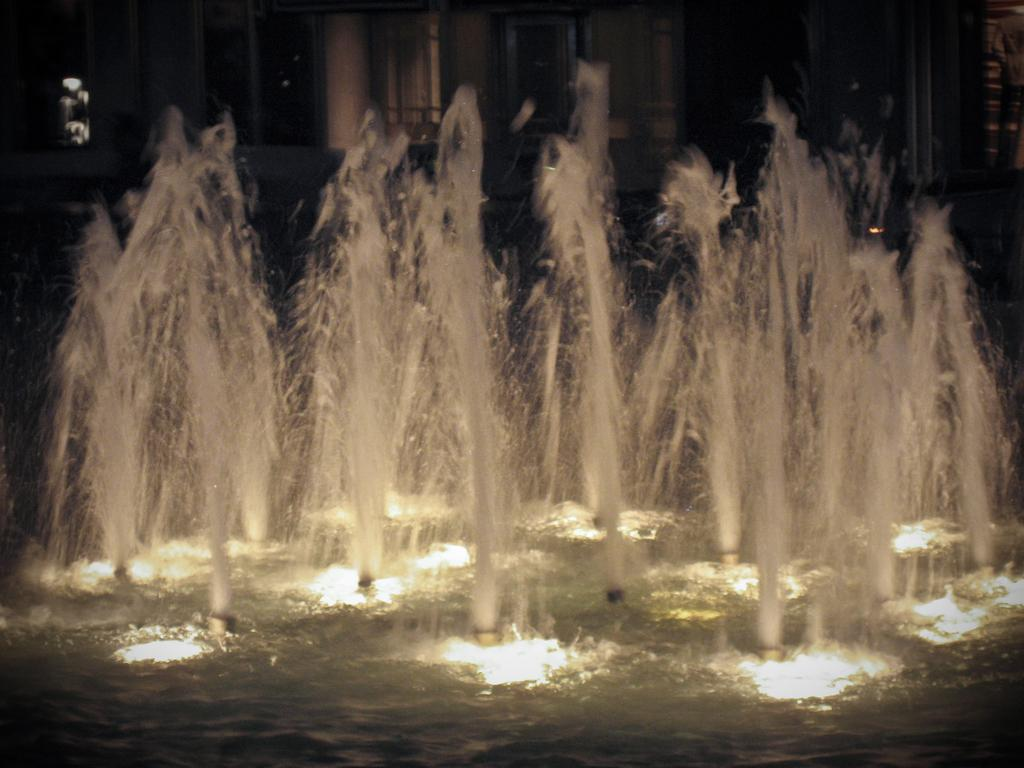What is the main subject in the foreground of the image? There is a fountain in the foreground of the image. What can be seen in the background of the image? There is a building in the background of the image. What is the primary element visible in the image? Water is visible in the image. Can you tell me how many quarters are floating in the water in the image? There are no quarters visible in the image; it features a fountain and water. What type of notebook is being used to write near the fountain in the image? There is no notebook present in the image. 